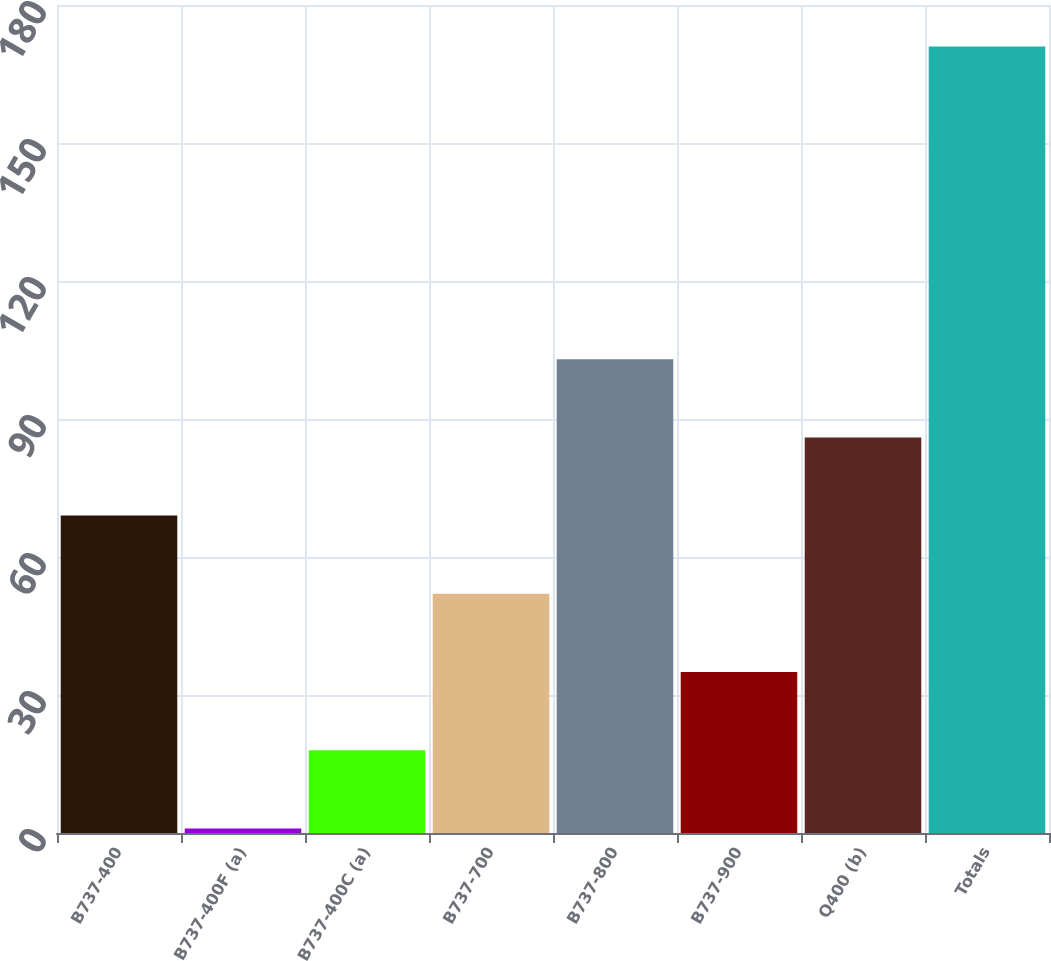Convert chart to OTSL. <chart><loc_0><loc_0><loc_500><loc_500><bar_chart><fcel>B737-400<fcel>B737-400F (a)<fcel>B737-400C (a)<fcel>B737-700<fcel>B737-800<fcel>B737-900<fcel>Q400 (b)<fcel>Totals<nl><fcel>69<fcel>1<fcel>18<fcel>52<fcel>103<fcel>35<fcel>86<fcel>171<nl></chart> 